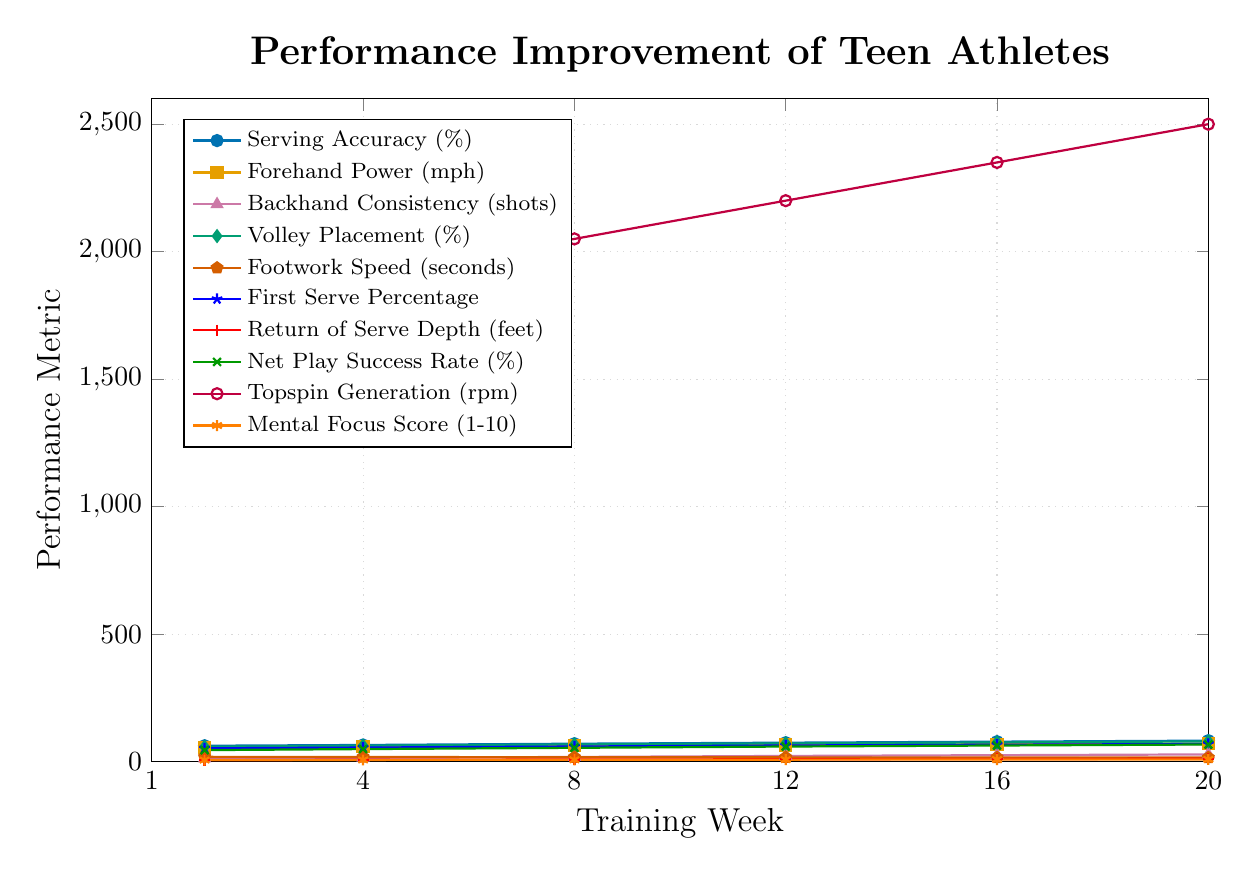Which skill shows the largest improvement over the training season? To determine the largest improvement, we compare the initial and final values for each skill. The difference for each skill is:
- Serving Accuracy: 82 - 62 = 20%
- Forehand Power: 70 - 55 = 15 mph
- Backhand Consistency: 28 - 12 = 16 shots
- Volley Placement: 79 - 58 = 21%
- Footwork Speed: 18.5 - 15.6 = 2.9 seconds (decrease)
- First Serve Percentage: 69 - 52 = 17%
- Return of Serve Depth: 11 - 6 = 5 feet
- Net Play Success Rate: 67 - 45 = 22%
- Topspin Generation: 2500 - 1800 = 700 rpm
- Mental Focus Score: 8.5 - 6 = 2.5
The skill with the largest improvement is Topspin Generation with an increase of 700 rpm.
Answer: Topspin Generation What is the average Serving Accuracy (%) across the 20 weeks? To calculate the average, sum the values for Serving Accuracy and divide by the number of data points: (62 + 65 + 70 + 74 + 78 + 82) / 6 = 431 / 6 ≈ 71.83
Answer: 71.83% Which two weeks have the largest difference in Footwork Speed? To find the largest difference, we calculate the absolute differences between consecutive weeks:
- Week 1 to 4: 18.5 - 17.8 = 0.7
- Week 4 to 8: 17.8 - 17.1 = 0.7
- Week 8 to 12: 17.1 - 16.5 = 0.6
- Week 12 to 16: 16.5 - 16.0 = 0.5
- Week 16 to 20: 16.0 - 15.6 = 0.4
The largest difference is 0.7 seconds between Week 1 and Week 4, and also between Week 4 and Week 8.
Answer: Week 1 to Week 4 and Week 4 to Week 8 How does Volley Placement (%) at Week 8 compare to First Serve Percentage at Week 12? At Week 8, Volley Placement is 67%, and at Week 12, First Serve Percentage is 63%. Comparing these values, Volley Placement is greater than First Serve Percentage.
Answer: Volley Placement is greater than First Serve Percentage By how many shots did Backhand Consistency increase from Week 4 to Week 12? The number of shots for Backhand Consistency at Week 4 is 15 and at Week 12 is 22. The increase from Week 4 to Week 12 is 22 - 15 = 7 shots.
Answer: 7 shots Which skill has the least visual improvement across the training season? To determine the least improvement visually, we check the magnitude of changes:
- Most metrics show significant changes except for Mental Focus Score, which only increased from 6 to 8.5 on a scale of 1 to 10.
Mental Focus Score shows the least visual improvement across the training season.
Answer: Mental Focus Score What is the range of Topspin Generation (rpm) throughout the training season? The range is calculated by subtracting the minimum value from the maximum value of Topspin Generation: 2500 (max) - 1800 (min) = 700 rpm.
Answer: 700 rpm Compare the trend in Volley Placement (%) with Net Play Success Rate (%) over time. Both Volley Placement and Net Play Success Rate show an increasing trend over time, but Volley Placement starts at 58% and ends at 79%, while Net Play Success Rate starts at 45% and ends at 67%. Volley Placement has a higher starting and ending value compared to Net Play Success Rate.
Answer: Both increase, but Volley Placement starts and ends higher 